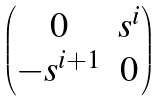Convert formula to latex. <formula><loc_0><loc_0><loc_500><loc_500>\begin{pmatrix} 0 & s ^ { i } \\ - s ^ { i + 1 } & 0 \end{pmatrix}</formula> 